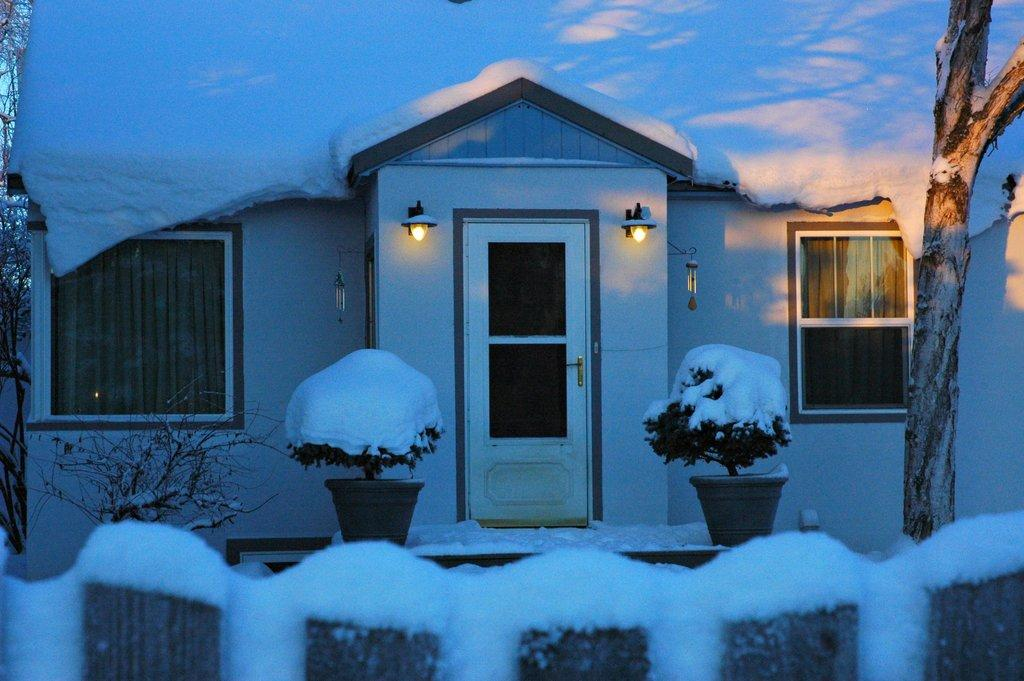What is the predominant weather condition in the image? There is snow in the image, indicating a cold and wintry condition. What type of structure can be seen in the image? There is a house in the image. What type of vegetation is present in the image? There are trees and shrubs in the image. What can be seen illuminating the scene in the image? There are lights in the image. What type of lumber is being used to construct the house in the image? There is no information about the type of lumber used to construct the house in the image. Can you see a ring on any of the trees in the image? There is no ring visible on any of the trees in the image. 